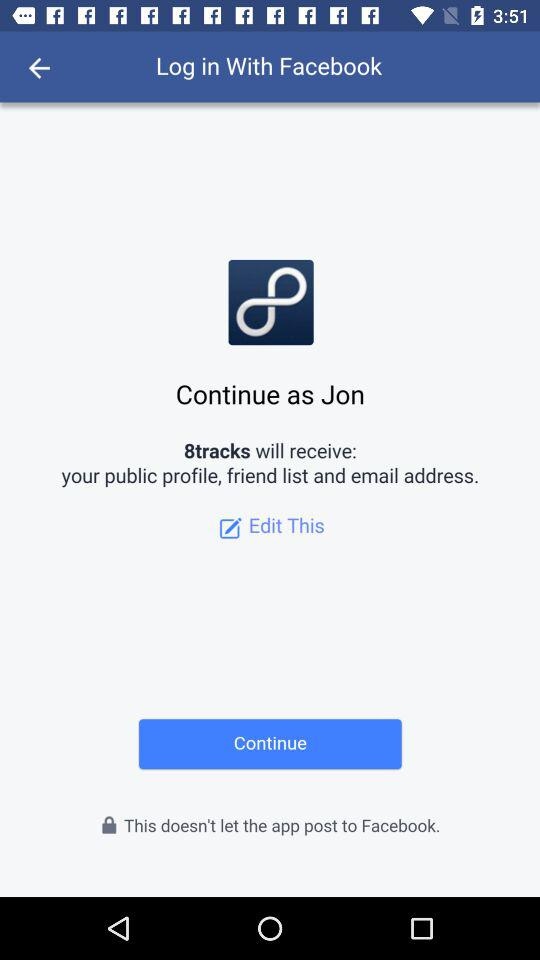What's the email address?
When the provided information is insufficient, respond with <no answer>. <no answer> 